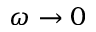<formula> <loc_0><loc_0><loc_500><loc_500>\omega \rightarrow 0</formula> 